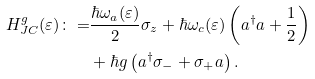Convert formula to latex. <formula><loc_0><loc_0><loc_500><loc_500>H _ { J C } ^ { g } ( \varepsilon ) \colon = & \frac { \hbar { \omega } _ { a } ( \varepsilon ) } { 2 } \sigma _ { z } + \hbar { \omega } _ { c } ( \varepsilon ) \left ( a ^ { \dagger } a + \frac { 1 } { 2 } \right ) \\ & + \hbar { g } \left ( a ^ { \dagger } \sigma _ { - } + \sigma _ { + } a \right ) .</formula> 